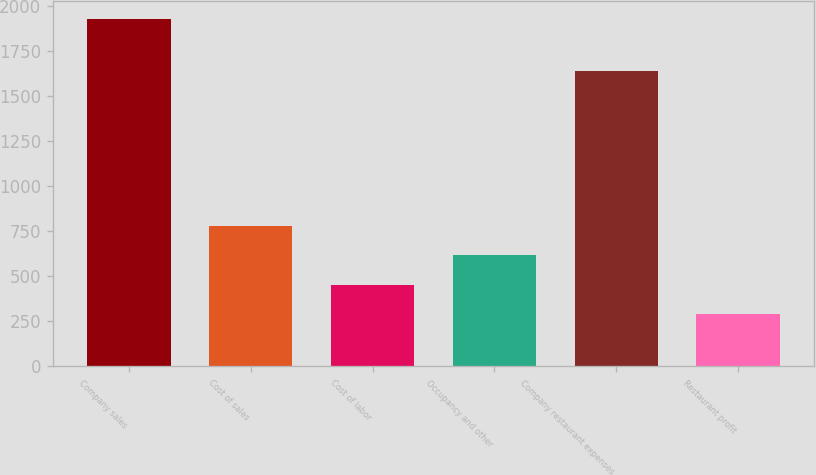Convert chart. <chart><loc_0><loc_0><loc_500><loc_500><bar_chart><fcel>Company sales<fcel>Cost of sales<fcel>Cost of labor<fcel>Occupancy and other<fcel>Company restaurant expenses<fcel>Restaurant profit<nl><fcel>1928<fcel>780.7<fcel>452.9<fcel>616.8<fcel>1639<fcel>289<nl></chart> 